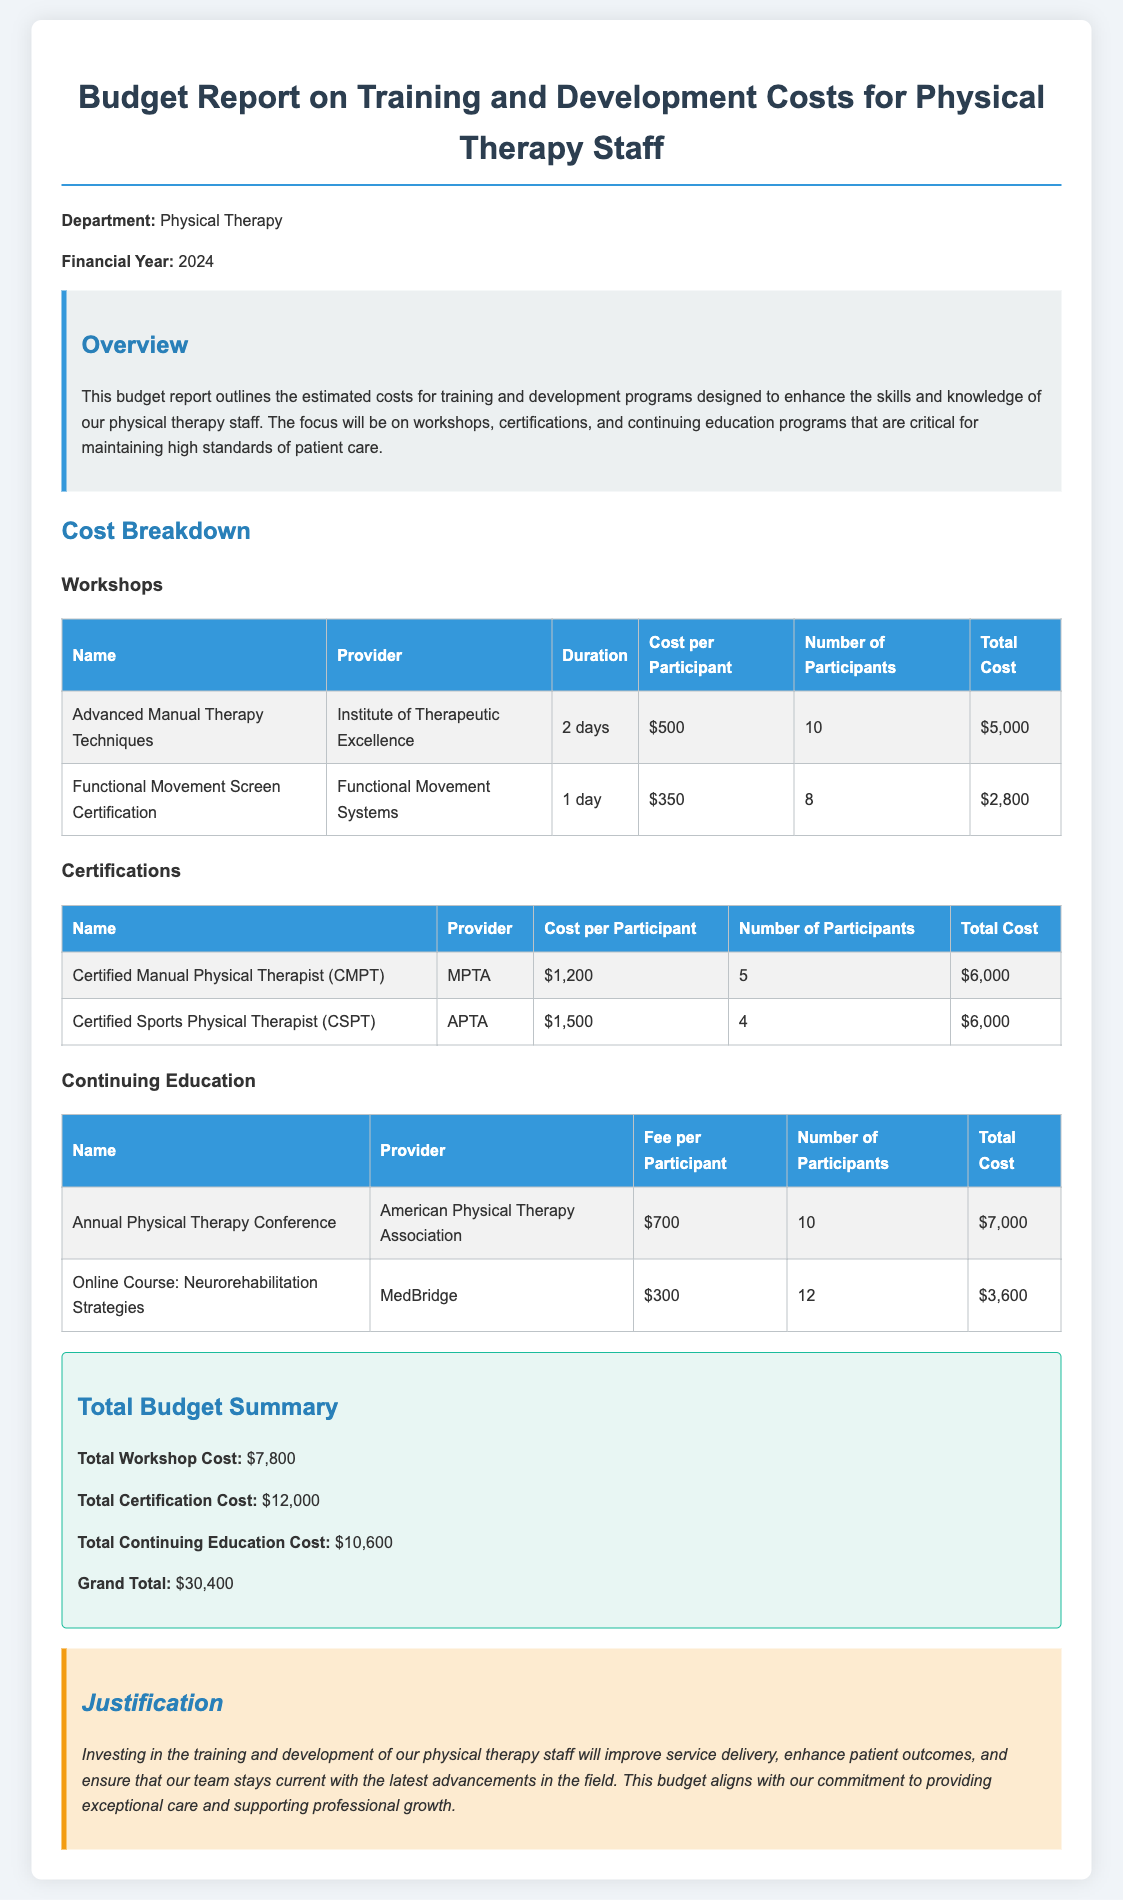What is the total cost for the Advanced Manual Therapy Techniques workshop? The total cost for this workshop is listed in the Cost Breakdown section as $5,000.
Answer: $5,000 How many participants are involved in the Certified Sports Physical Therapist certification? This information is found in the Certifications table, where it states 4 participants for this certification.
Answer: 4 What is the total budget for training and development costs? The total budget is summarized in the Total Budget Summary as $30,400.
Answer: $30,400 Who is the provider for the Annual Physical Therapy Conference? The provider for this event is mentioned in the Continuing Education table as the American Physical Therapy Association.
Answer: American Physical Therapy Association What was the cost per participant for the Neurorehabilitation Strategies online course? It is explicitly stated in the Continuing Education table that the fee per participant is $300.
Answer: $300 How many workshops are outlined in the document? The document lists two workshops in the Cost Breakdown section.
Answer: 2 What is the cost for the Functional Movement Screen Certification? The total cost for this certification is specified as $2,800 in the Workshops section.
Answer: $2,800 Why is the investment in training and development justified? The justification points to improved service delivery and enhanced patient outcomes as key reasons mentioned in the Justification section.
Answer: Improved service delivery and enhanced patient outcomes 